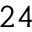Convert formula to latex. <formula><loc_0><loc_0><loc_500><loc_500>2 4</formula> 